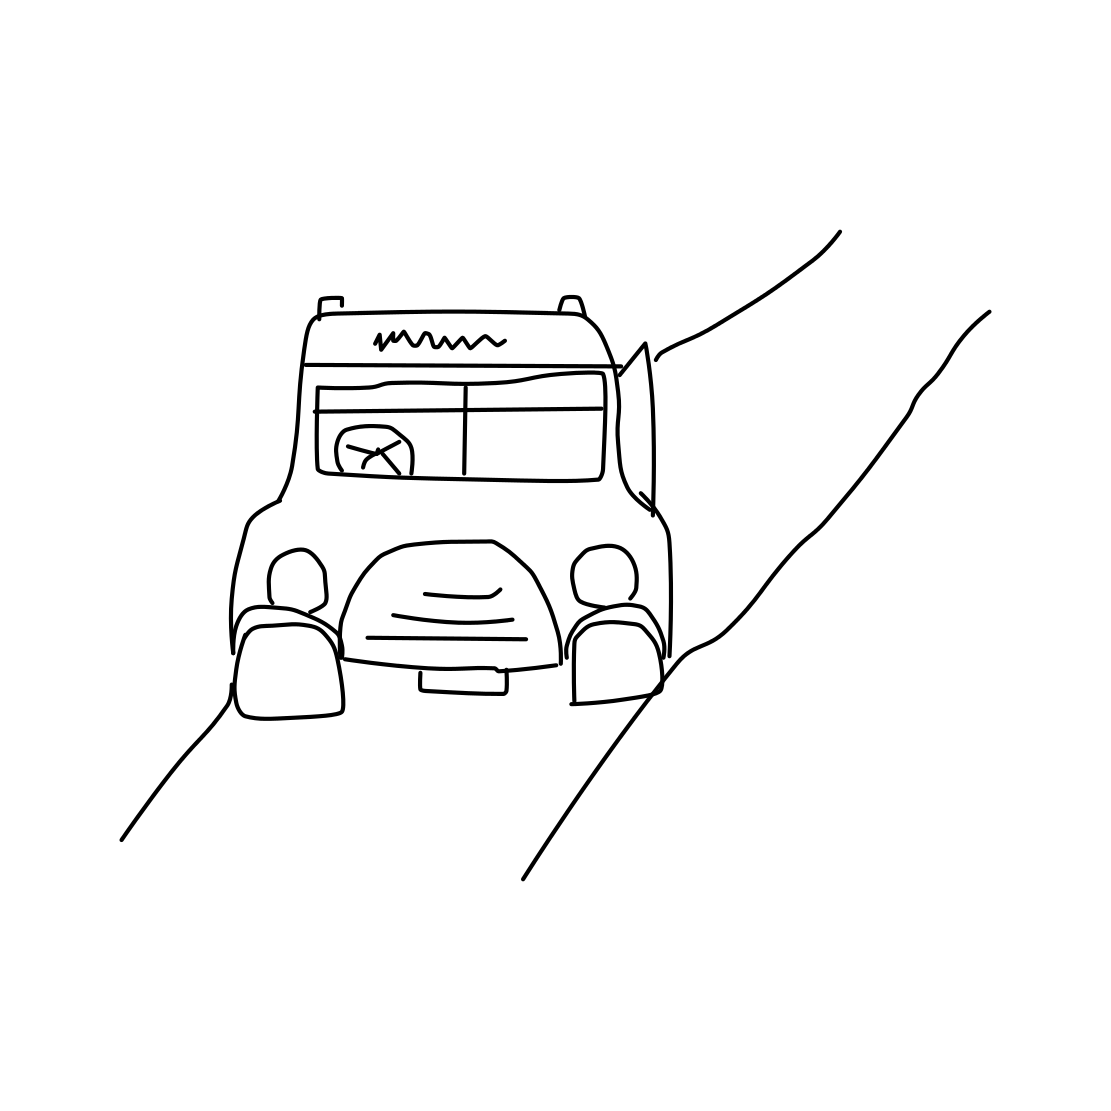Can you describe the style or era of the truck depicted in the image? The style of the truck in the image appears reminiscent of mid-20th-century designs with its rounded body and simple details, suggesting a classic or vintage look often associated with simplicity and nostalgia. 